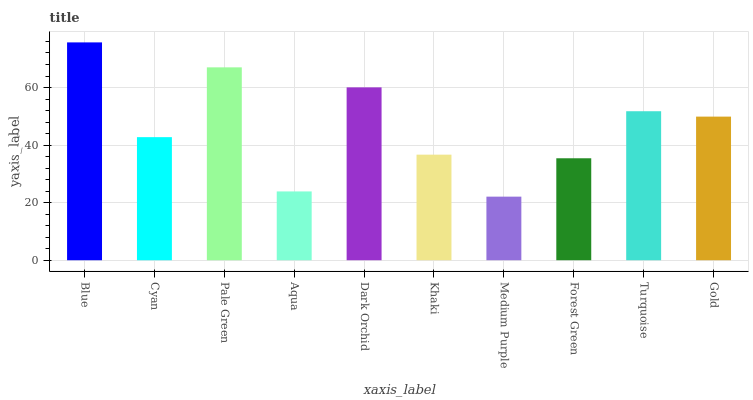Is Cyan the minimum?
Answer yes or no. No. Is Cyan the maximum?
Answer yes or no. No. Is Blue greater than Cyan?
Answer yes or no. Yes. Is Cyan less than Blue?
Answer yes or no. Yes. Is Cyan greater than Blue?
Answer yes or no. No. Is Blue less than Cyan?
Answer yes or no. No. Is Gold the high median?
Answer yes or no. Yes. Is Cyan the low median?
Answer yes or no. Yes. Is Khaki the high median?
Answer yes or no. No. Is Gold the low median?
Answer yes or no. No. 